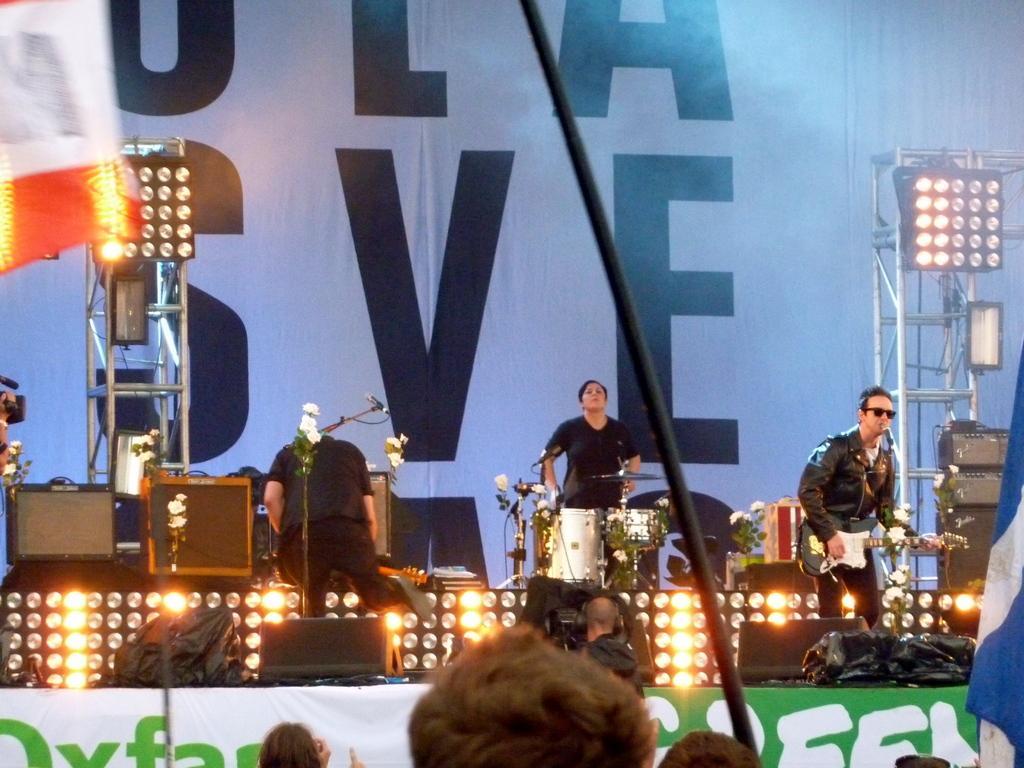Can you describe this image briefly? In this image i can see few people standing and holding a musical instruments in their hand. In the background i can see a huge banner, lights and a stage. 